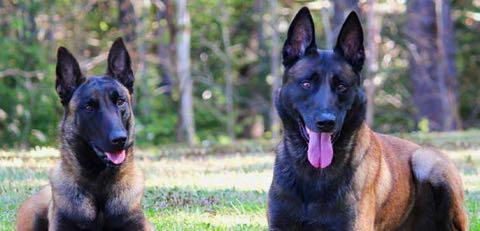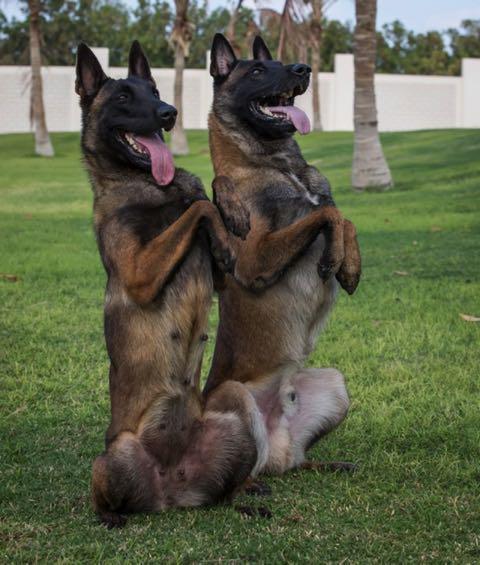The first image is the image on the left, the second image is the image on the right. Given the left and right images, does the statement "There are 2 or more German Shepard's laying down on grass." hold true? Answer yes or no. No. The first image is the image on the left, the second image is the image on the right. Examine the images to the left and right. Is the description "At least two dogs are lying down on the ground." accurate? Answer yes or no. No. 